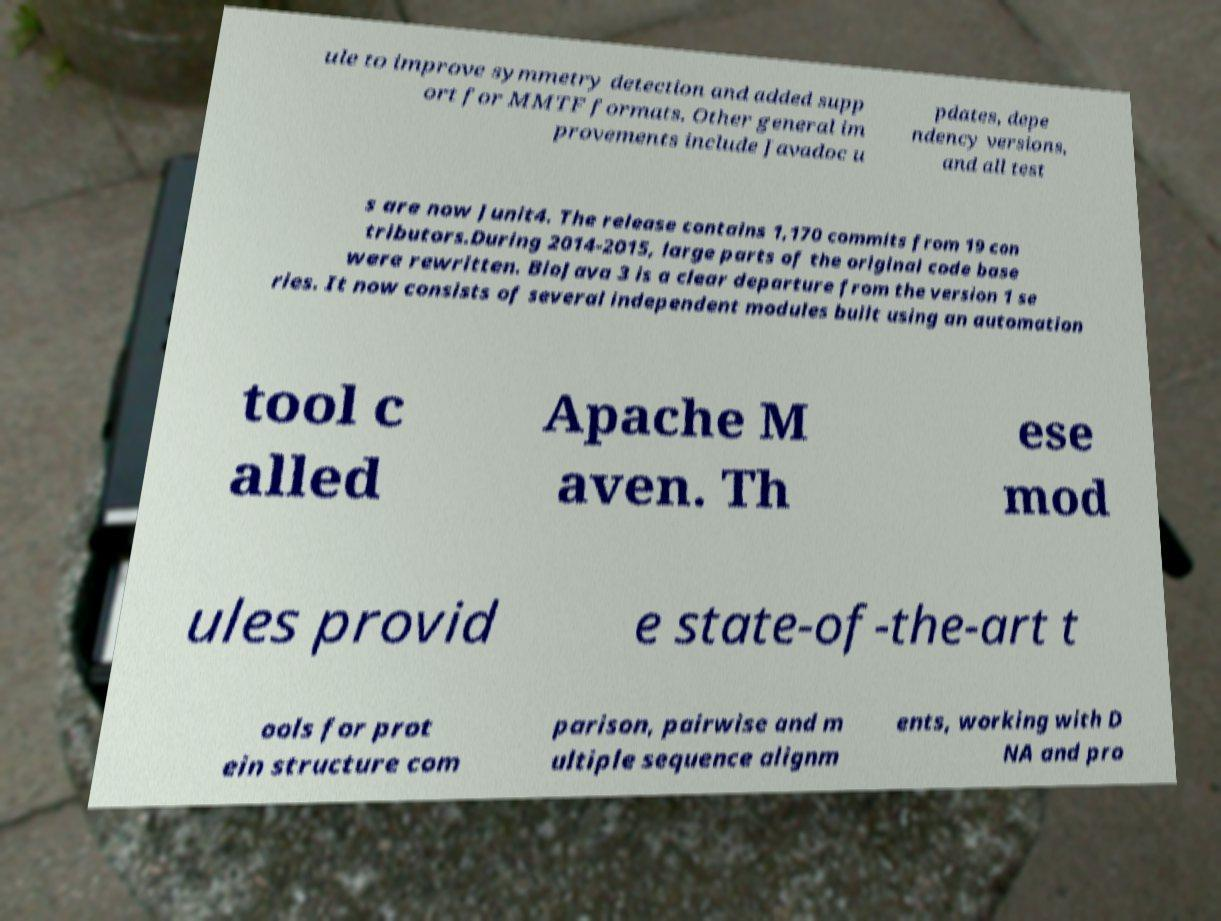I need the written content from this picture converted into text. Can you do that? ule to improve symmetry detection and added supp ort for MMTF formats. Other general im provements include Javadoc u pdates, depe ndency versions, and all test s are now Junit4. The release contains 1,170 commits from 19 con tributors.During 2014-2015, large parts of the original code base were rewritten. BioJava 3 is a clear departure from the version 1 se ries. It now consists of several independent modules built using an automation tool c alled Apache M aven. Th ese mod ules provid e state-of-the-art t ools for prot ein structure com parison, pairwise and m ultiple sequence alignm ents, working with D NA and pro 